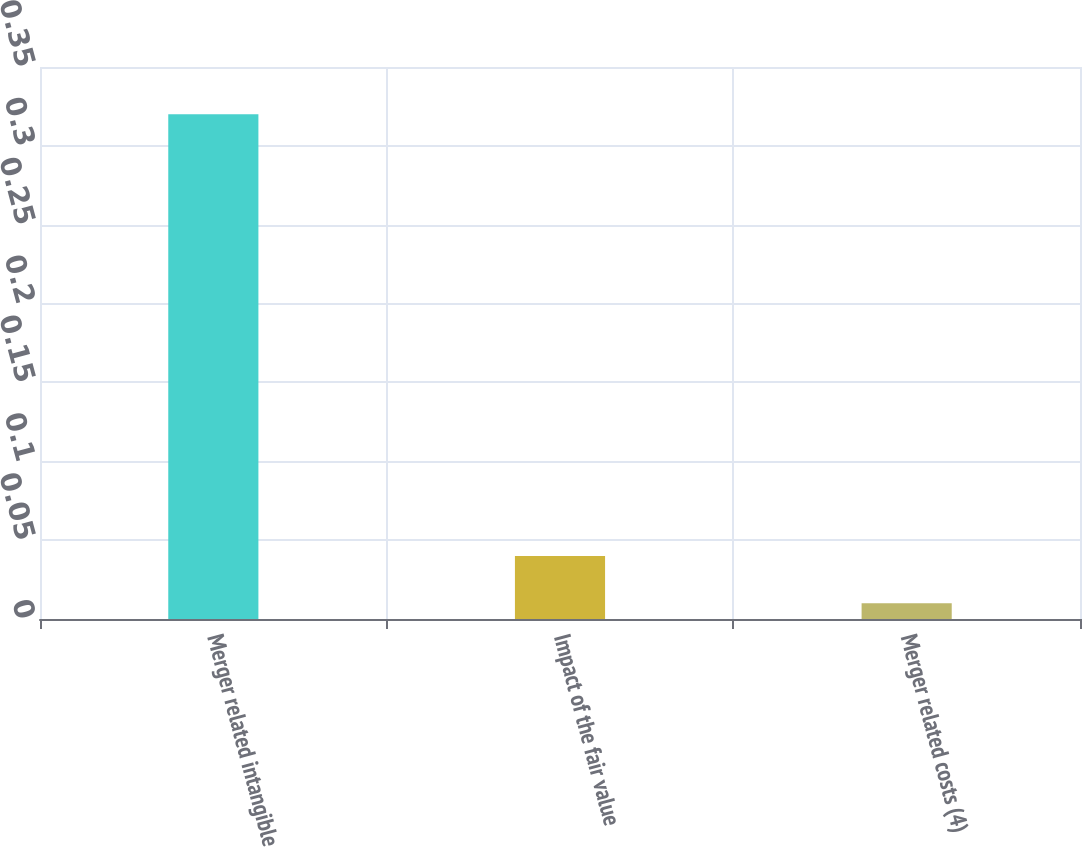<chart> <loc_0><loc_0><loc_500><loc_500><bar_chart><fcel>Merger related intangible<fcel>Impact of the fair value<fcel>Merger related costs (4)<nl><fcel>0.32<fcel>0.04<fcel>0.01<nl></chart> 